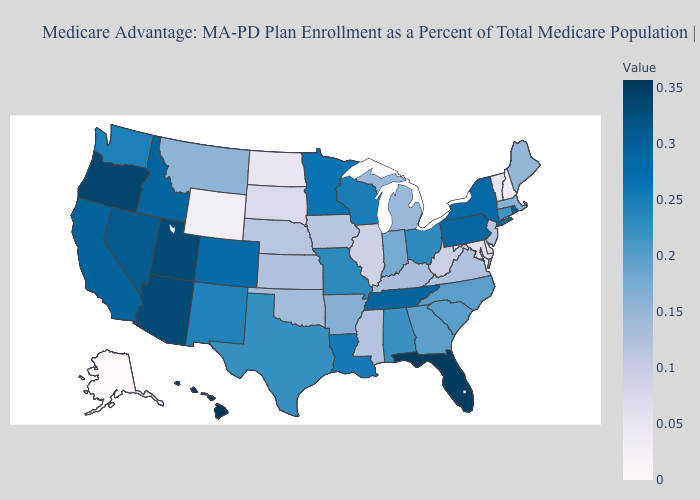Does Massachusetts have a higher value than Missouri?
Be succinct. No. Does Iowa have the highest value in the MidWest?
Quick response, please. No. Which states have the lowest value in the USA?
Answer briefly. Alaska. 